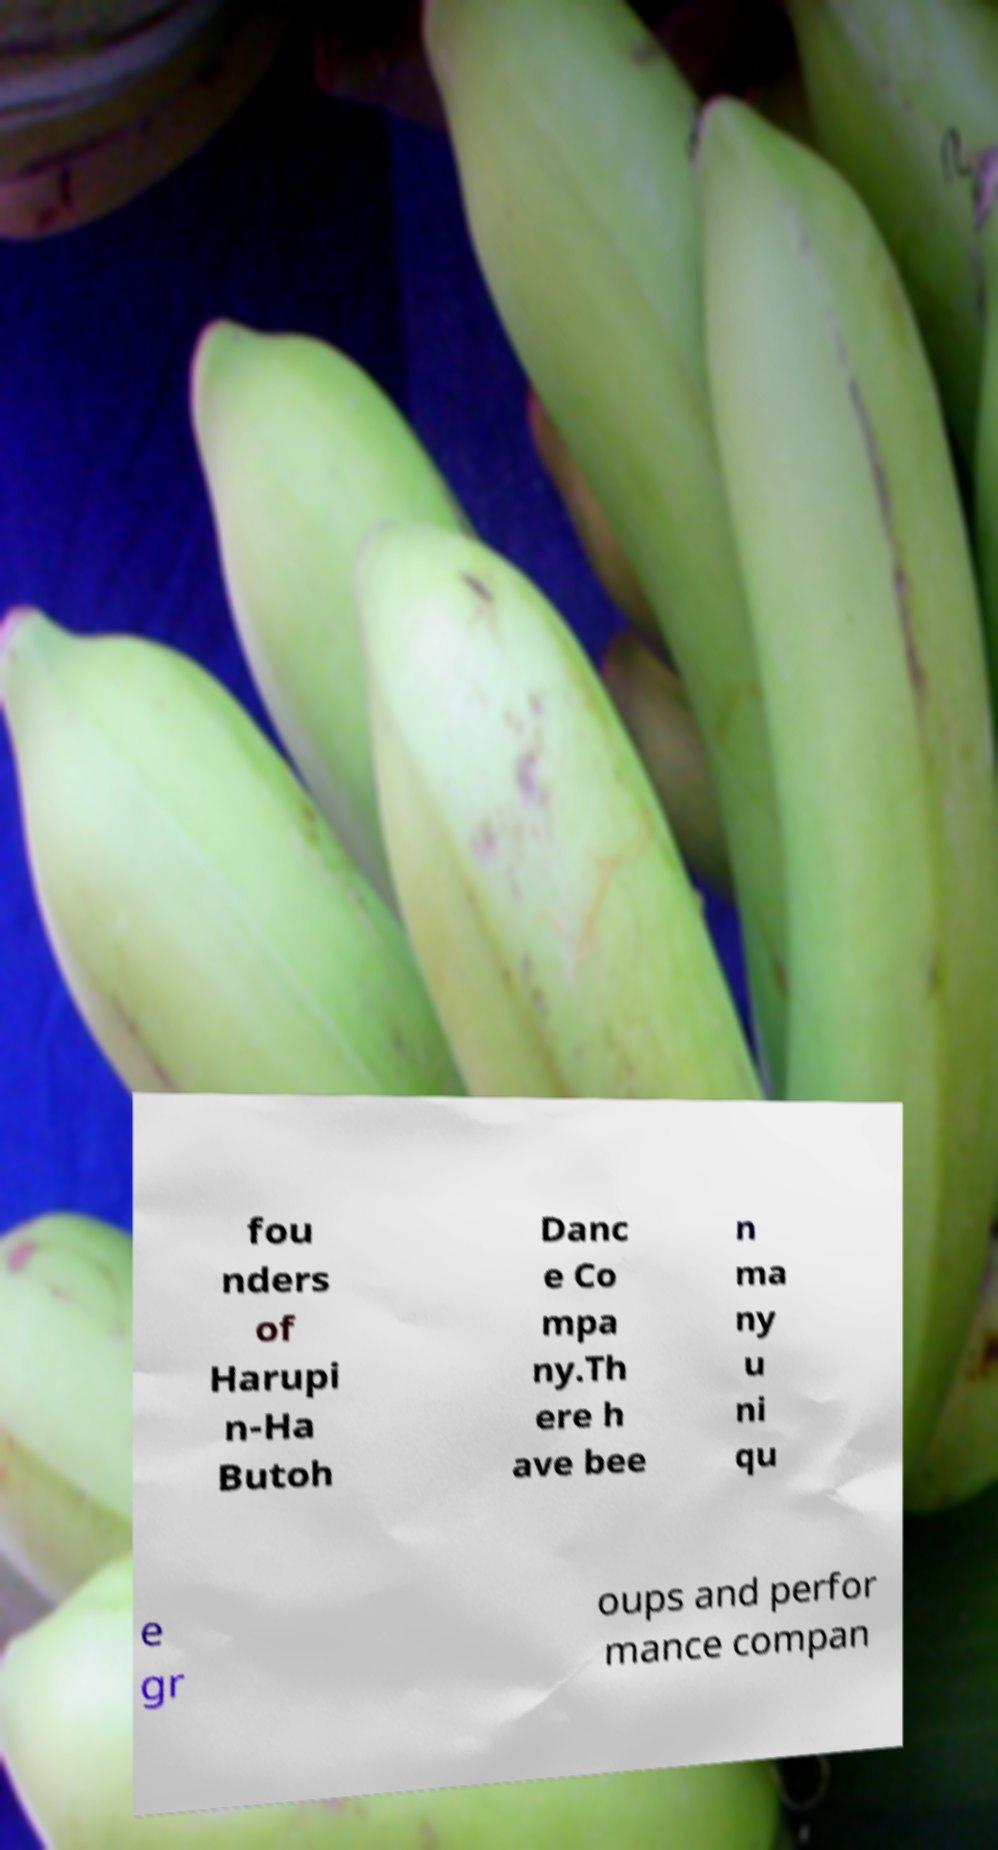Please read and relay the text visible in this image. What does it say? fou nders of Harupi n-Ha Butoh Danc e Co mpa ny.Th ere h ave bee n ma ny u ni qu e gr oups and perfor mance compan 